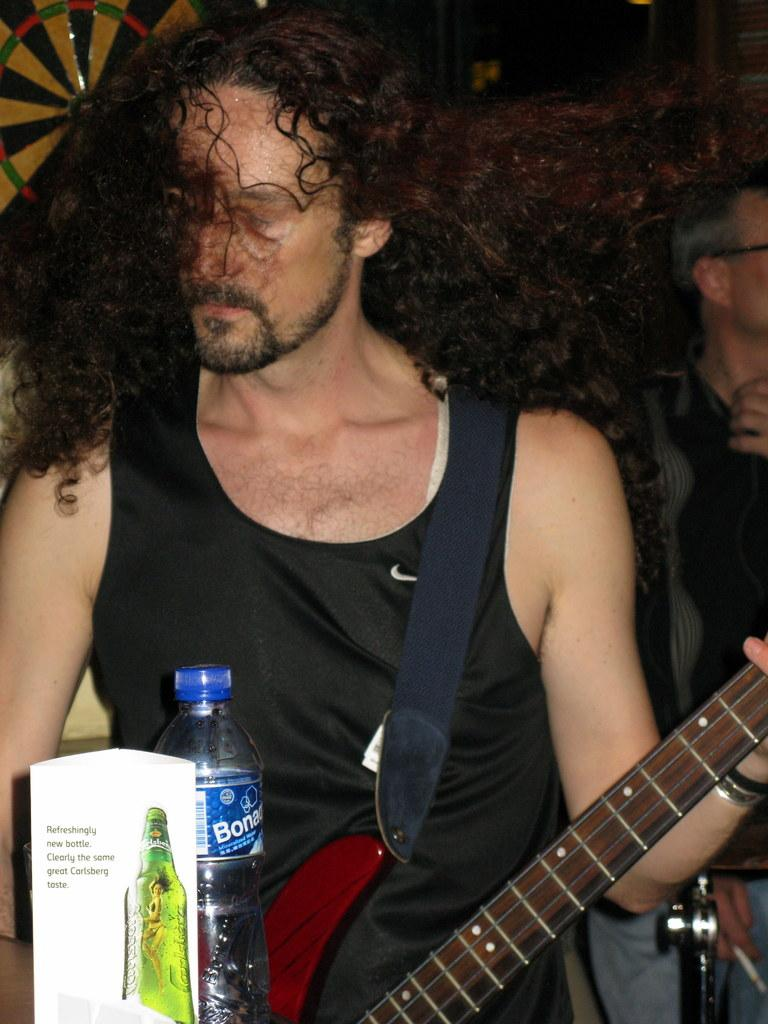What is the man in the image doing? The man is playing a guitar in the image. What object is in front of the man? There is a bottle in front of the man. How far is the man from the speaker? The man is standing far from the speaker. What type of meat is the man grilling in the image? There is no meat or grill present in the image; the man is playing a guitar. How does the man control the unit in the image? There is no unit or control mechanism mentioned in the image; the man is playing a guitar. 